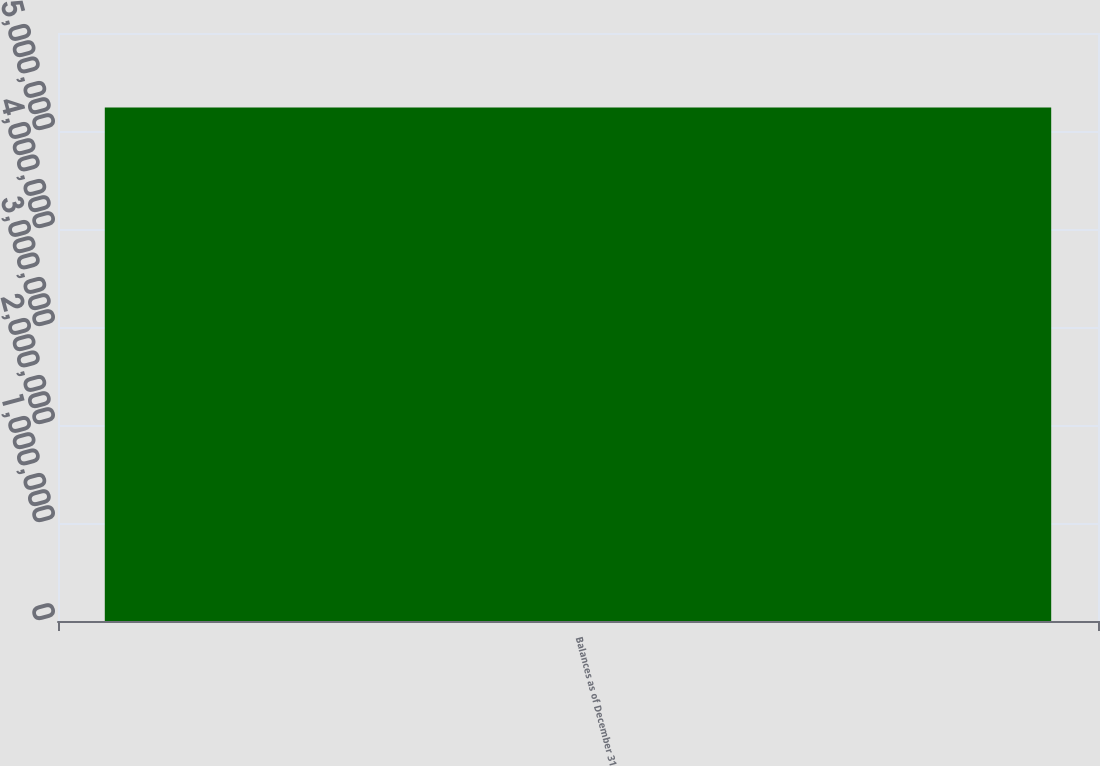Convert chart. <chart><loc_0><loc_0><loc_500><loc_500><bar_chart><fcel>Balances as of December 31<nl><fcel>5.23876e+06<nl></chart> 